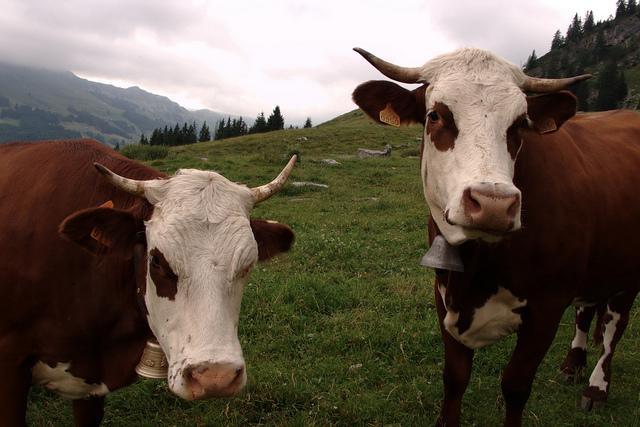Why is the cows two different colors?
Keep it brief. Breeding. What are the cows standing on?
Concise answer only. Grass. How can you hear the cows walking around?
Keep it brief. Bells. Is there ocean water in the background?
Write a very short answer. No. What is in the animal's ear?
Concise answer only. Tag. What are the cows doing?
Give a very brief answer. Standing. 